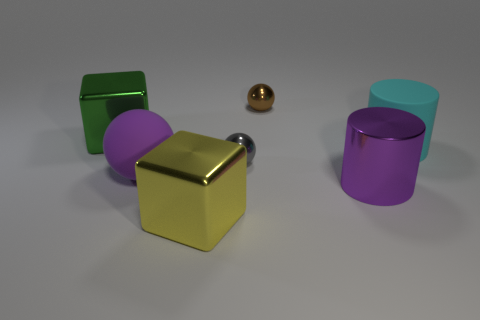What could be the context or purpose of this arrangement of objects? This arrangement of objects might be a part of a visual study in computer graphics, focusing on the behavior of different materials and shapes under uniform lighting, or it could be an artistic composition intended to emphasize color and form contrasts.  What do the varying shapes and colors of the objects suggest? The variation in shapes and colors might suggest an exploration of geometric diversity and a playful contrast in hues, offering a visual feast that could symbolize variety and creativity. 